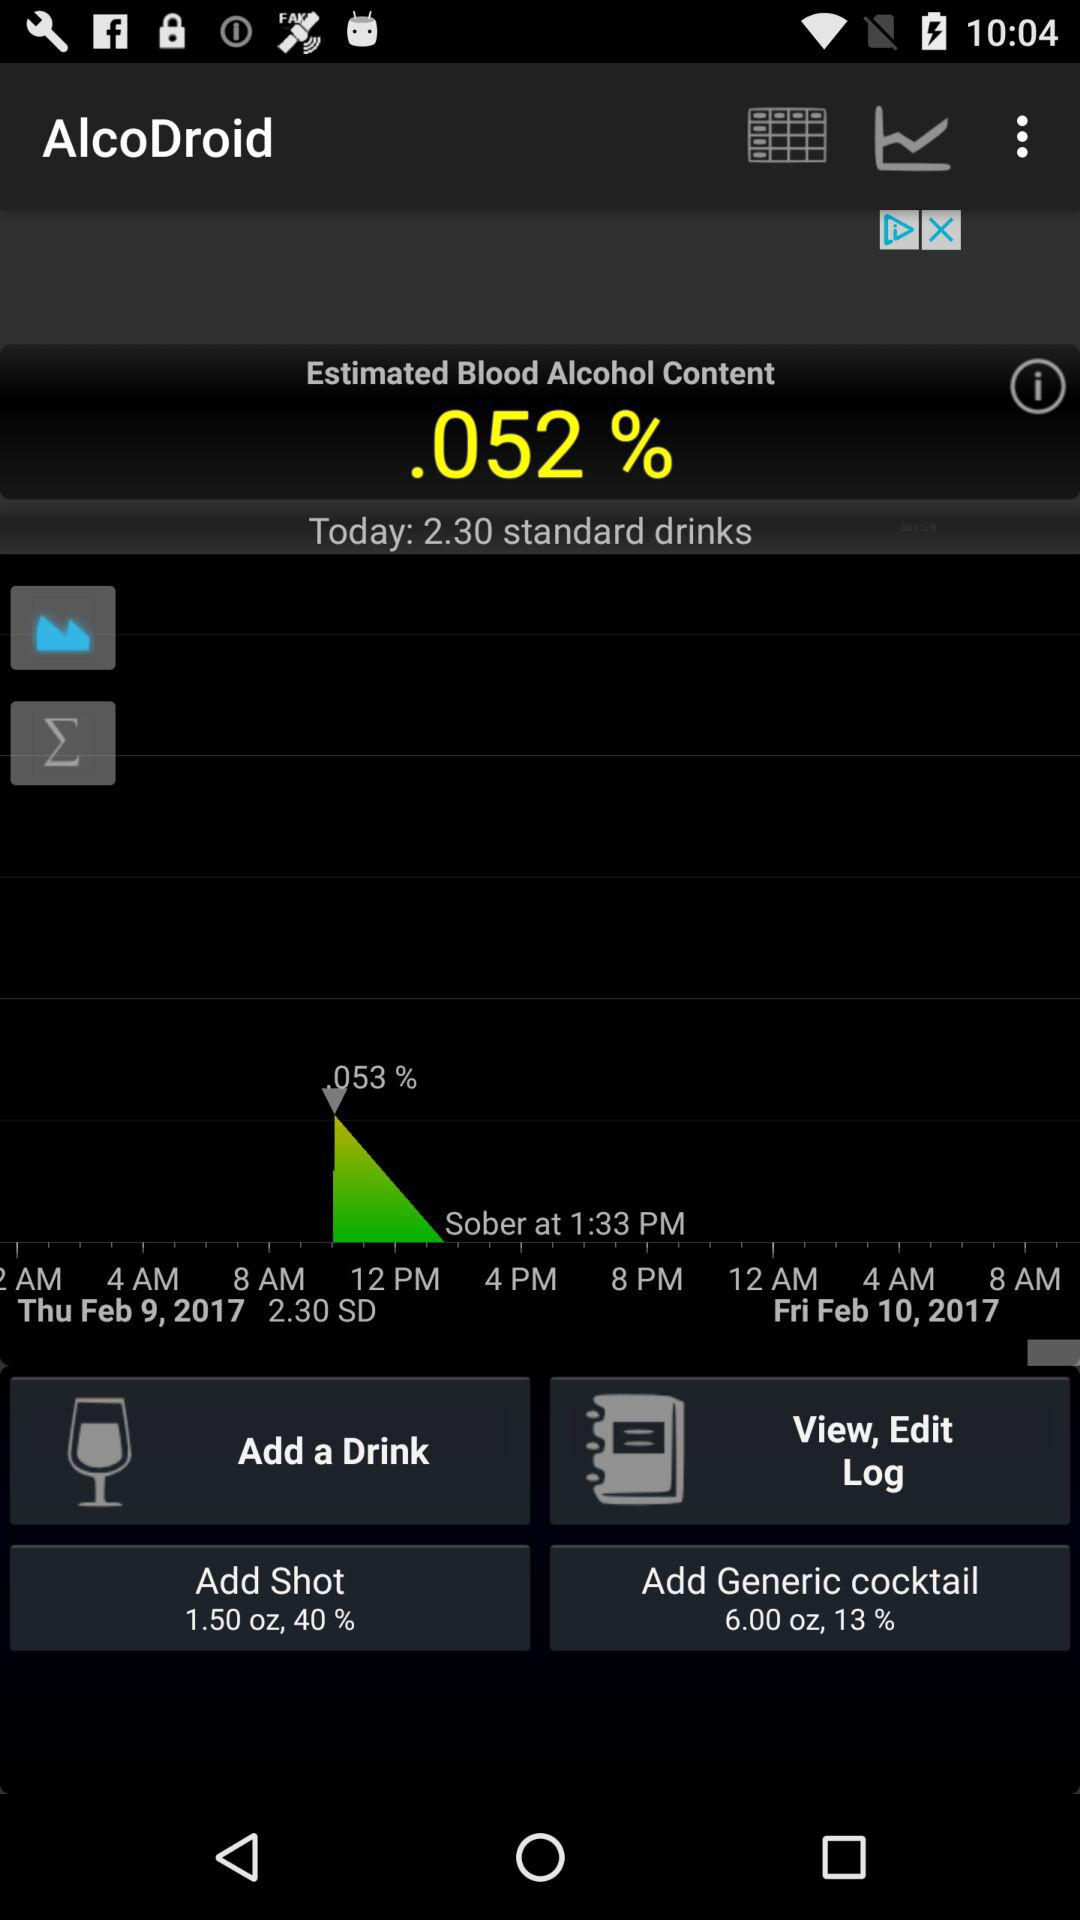What is the day and date? The days are Thursday and Friday and the dates are February 9, 2017 and February 10, 2017. 